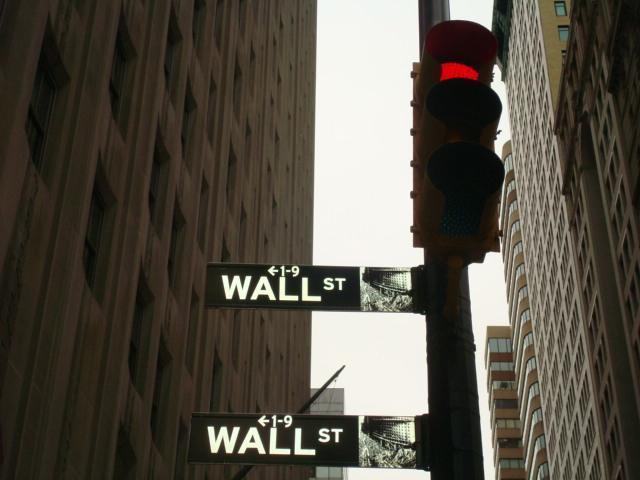How many identical signs are there?
Give a very brief answer. 2. 